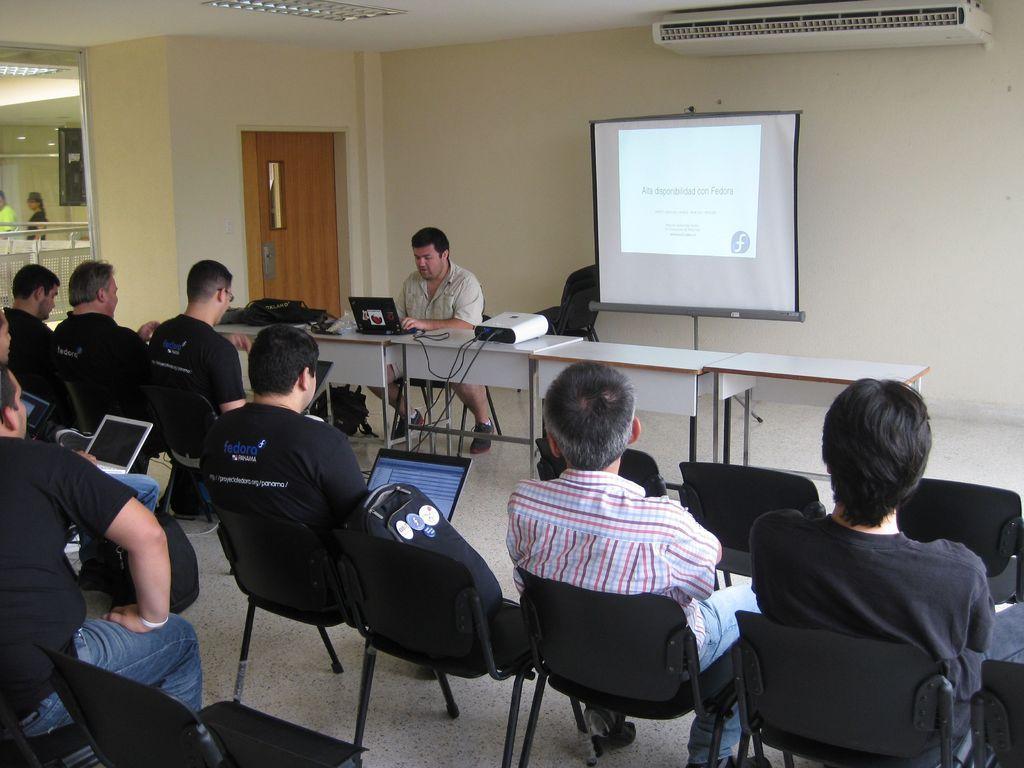Describe this image in one or two sentences. At the bottom of the image there are people sitting on the chairs. There are tables. In the center of the image there is a screen. In the background there is a wall and a door. 